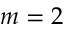Convert formula to latex. <formula><loc_0><loc_0><loc_500><loc_500>m = 2</formula> 